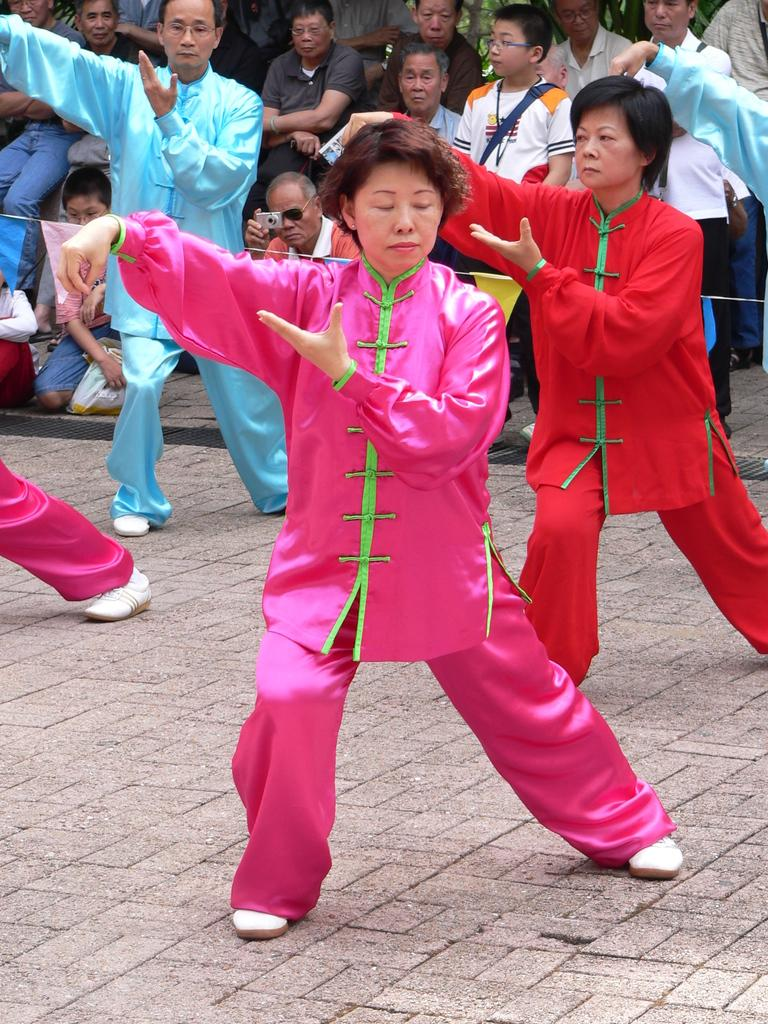What can be seen in the background of the image? There are people in the background of the image. What are the people wearing? The people are wearing colorful dresses. What are the people doing in the image? The people appear to be dancing on the floor. What type of spoon is being used by the people in the image? There is no spoon present in the image; the people are dancing on the floor. 